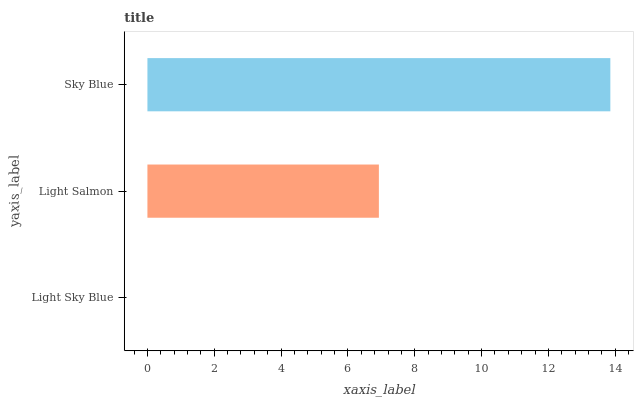Is Light Sky Blue the minimum?
Answer yes or no. Yes. Is Sky Blue the maximum?
Answer yes or no. Yes. Is Light Salmon the minimum?
Answer yes or no. No. Is Light Salmon the maximum?
Answer yes or no. No. Is Light Salmon greater than Light Sky Blue?
Answer yes or no. Yes. Is Light Sky Blue less than Light Salmon?
Answer yes or no. Yes. Is Light Sky Blue greater than Light Salmon?
Answer yes or no. No. Is Light Salmon less than Light Sky Blue?
Answer yes or no. No. Is Light Salmon the high median?
Answer yes or no. Yes. Is Light Salmon the low median?
Answer yes or no. Yes. Is Light Sky Blue the high median?
Answer yes or no. No. Is Light Sky Blue the low median?
Answer yes or no. No. 